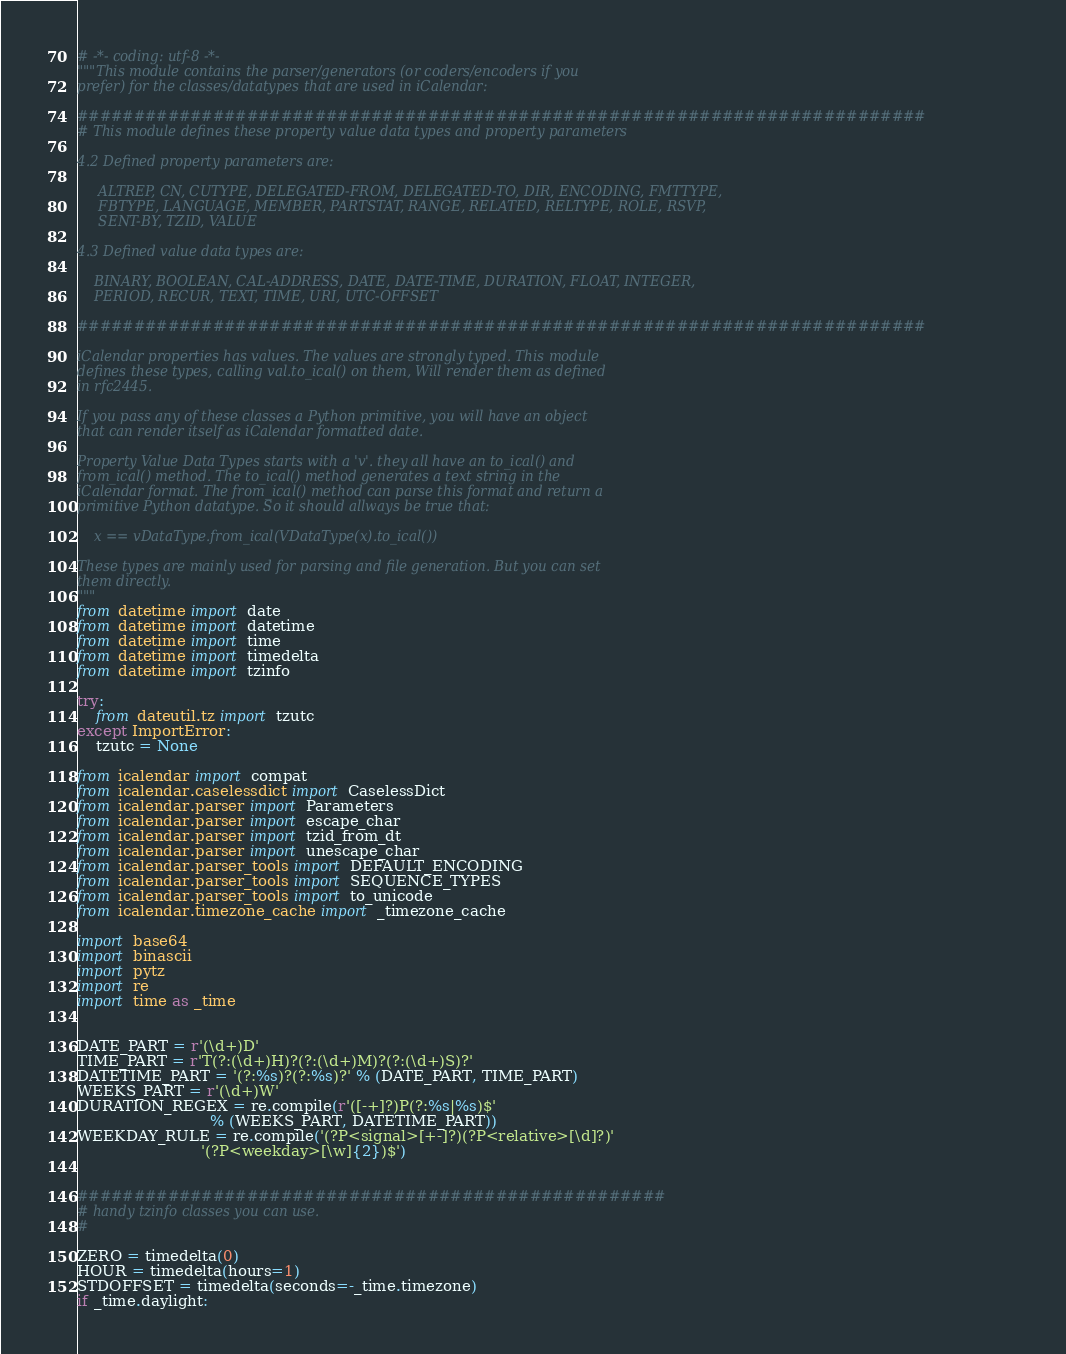Convert code to text. <code><loc_0><loc_0><loc_500><loc_500><_Python_># -*- coding: utf-8 -*-
"""This module contains the parser/generators (or coders/encoders if you
prefer) for the classes/datatypes that are used in iCalendar:

###########################################################################
# This module defines these property value data types and property parameters

4.2 Defined property parameters are:

     ALTREP, CN, CUTYPE, DELEGATED-FROM, DELEGATED-TO, DIR, ENCODING, FMTTYPE,
     FBTYPE, LANGUAGE, MEMBER, PARTSTAT, RANGE, RELATED, RELTYPE, ROLE, RSVP,
     SENT-BY, TZID, VALUE

4.3 Defined value data types are:

    BINARY, BOOLEAN, CAL-ADDRESS, DATE, DATE-TIME, DURATION, FLOAT, INTEGER,
    PERIOD, RECUR, TEXT, TIME, URI, UTC-OFFSET

###########################################################################

iCalendar properties has values. The values are strongly typed. This module
defines these types, calling val.to_ical() on them, Will render them as defined
in rfc2445.

If you pass any of these classes a Python primitive, you will have an object
that can render itself as iCalendar formatted date.

Property Value Data Types starts with a 'v'. they all have an to_ical() and
from_ical() method. The to_ical() method generates a text string in the
iCalendar format. The from_ical() method can parse this format and return a
primitive Python datatype. So it should allways be true that:

    x == vDataType.from_ical(VDataType(x).to_ical())

These types are mainly used for parsing and file generation. But you can set
them directly.
"""
from datetime import date
from datetime import datetime
from datetime import time
from datetime import timedelta
from datetime import tzinfo

try:
    from dateutil.tz import tzutc
except ImportError:
    tzutc = None

from icalendar import compat
from icalendar.caselessdict import CaselessDict
from icalendar.parser import Parameters
from icalendar.parser import escape_char
from icalendar.parser import tzid_from_dt
from icalendar.parser import unescape_char
from icalendar.parser_tools import DEFAULT_ENCODING
from icalendar.parser_tools import SEQUENCE_TYPES
from icalendar.parser_tools import to_unicode
from icalendar.timezone_cache import _timezone_cache

import base64
import binascii
import pytz
import re
import time as _time


DATE_PART = r'(\d+)D'
TIME_PART = r'T(?:(\d+)H)?(?:(\d+)M)?(?:(\d+)S)?'
DATETIME_PART = '(?:%s)?(?:%s)?' % (DATE_PART, TIME_PART)
WEEKS_PART = r'(\d+)W'
DURATION_REGEX = re.compile(r'([-+]?)P(?:%s|%s)$'
                            % (WEEKS_PART, DATETIME_PART))
WEEKDAY_RULE = re.compile('(?P<signal>[+-]?)(?P<relative>[\d]?)'
                          '(?P<weekday>[\w]{2})$')


####################################################
# handy tzinfo classes you can use.
#

ZERO = timedelta(0)
HOUR = timedelta(hours=1)
STDOFFSET = timedelta(seconds=-_time.timezone)
if _time.daylight:</code> 